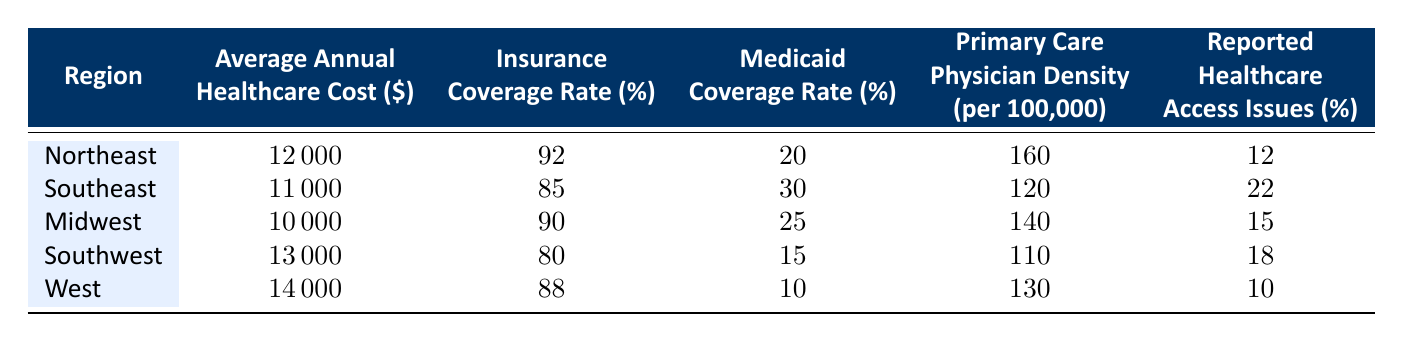What is the average annual healthcare cost in the Southeast region? The table shows that the Average Annual Healthcare Cost in the Southeast region is listed as 11,000.
Answer: 11,000 Which region has the highest insurance coverage rate? From the table, the Northeast region has the highest Insurance Coverage Rate at 92%.
Answer: Northeast Is the Medicaid Coverage Rate in the Midwest region higher than that in the Southwest region? The Medicaid Coverage Rate in the Midwest is 25%, while in the Southwest it is 15%. Since 25% > 15%, the statement is true.
Answer: Yes What is the difference in Average Annual Healthcare Costs between the West and Midwest regions? The Average Annual Healthcare Cost in the West is 14,000, and in the Midwest it is 10,000. The difference is calculated as 14,000 - 10,000 = 4,000.
Answer: 4,000 How many regions have reported healthcare access issues greater than 15%? The Southeast region has 22%, the Southwest has 18%, and the Midwest has 15%. Counting those, three regions (Southeast, Southwest) report issues greater than 15%.
Answer: 3 If we average the primary care physician density across all regions, what would it be? The densities are 160, 120, 140, 110, and 130. Summing these gives: 160 + 120 + 140 + 110 + 130 = 660. Dividing by 5 gives an average of 660 / 5 = 132.
Answer: 132 Is the average annual healthcare cost in the Northeast less than the Western region? The Average Annual Healthcare Cost in the Northeast is 12,000, while in the West it is 14,000. Since 12,000 < 14,000, the statement is false.
Answer: No Which region has the lowest number of reported healthcare access issues? The table lists the reported healthcare access issues for each region. The West has the lowest at 10%.
Answer: West What is the average Medicaid coverage rate across all regions? The total Medicaid coverage rates are 20, 30, 25, 15, and 10, which sum to 100. Dividing by the number of regions gives an average of 100 / 5 = 20%.
Answer: 20% 